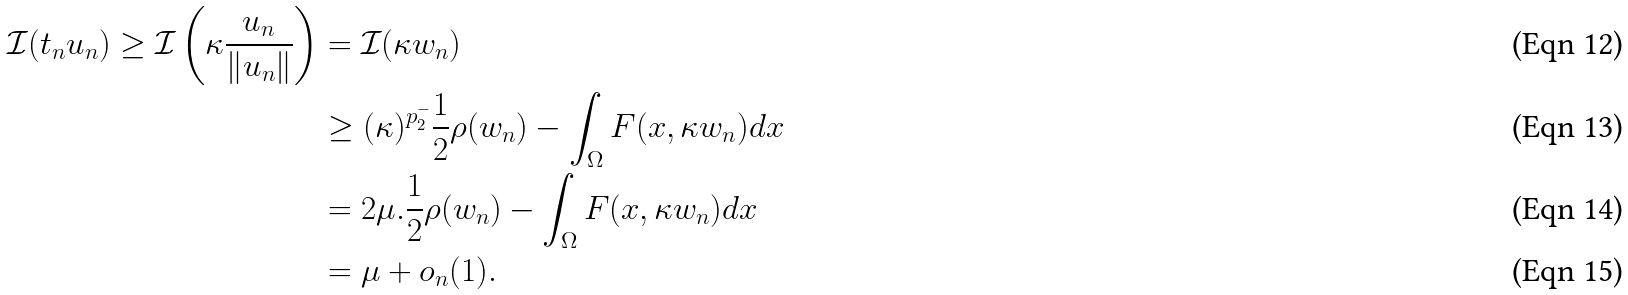Convert formula to latex. <formula><loc_0><loc_0><loc_500><loc_500>\mathcal { I } ( t _ { n } u _ { n } ) \geq \mathcal { I } \left ( \kappa \frac { u _ { n } } { \| u _ { n } \| } \right ) & = \mathcal { I } ( \kappa w _ { n } ) \\ & \geq ( \kappa ) ^ { p _ { 2 } ^ { - } } \frac { 1 } { 2 } \rho ( w _ { n } ) - \int _ { \Omega } F ( x , \kappa w _ { n } ) d x \\ & = 2 \mu . \frac { 1 } { 2 } \rho ( w _ { n } ) - \int _ { \Omega } F ( x , \kappa w _ { n } ) d x \\ & = \mu + o _ { n } ( 1 ) .</formula> 